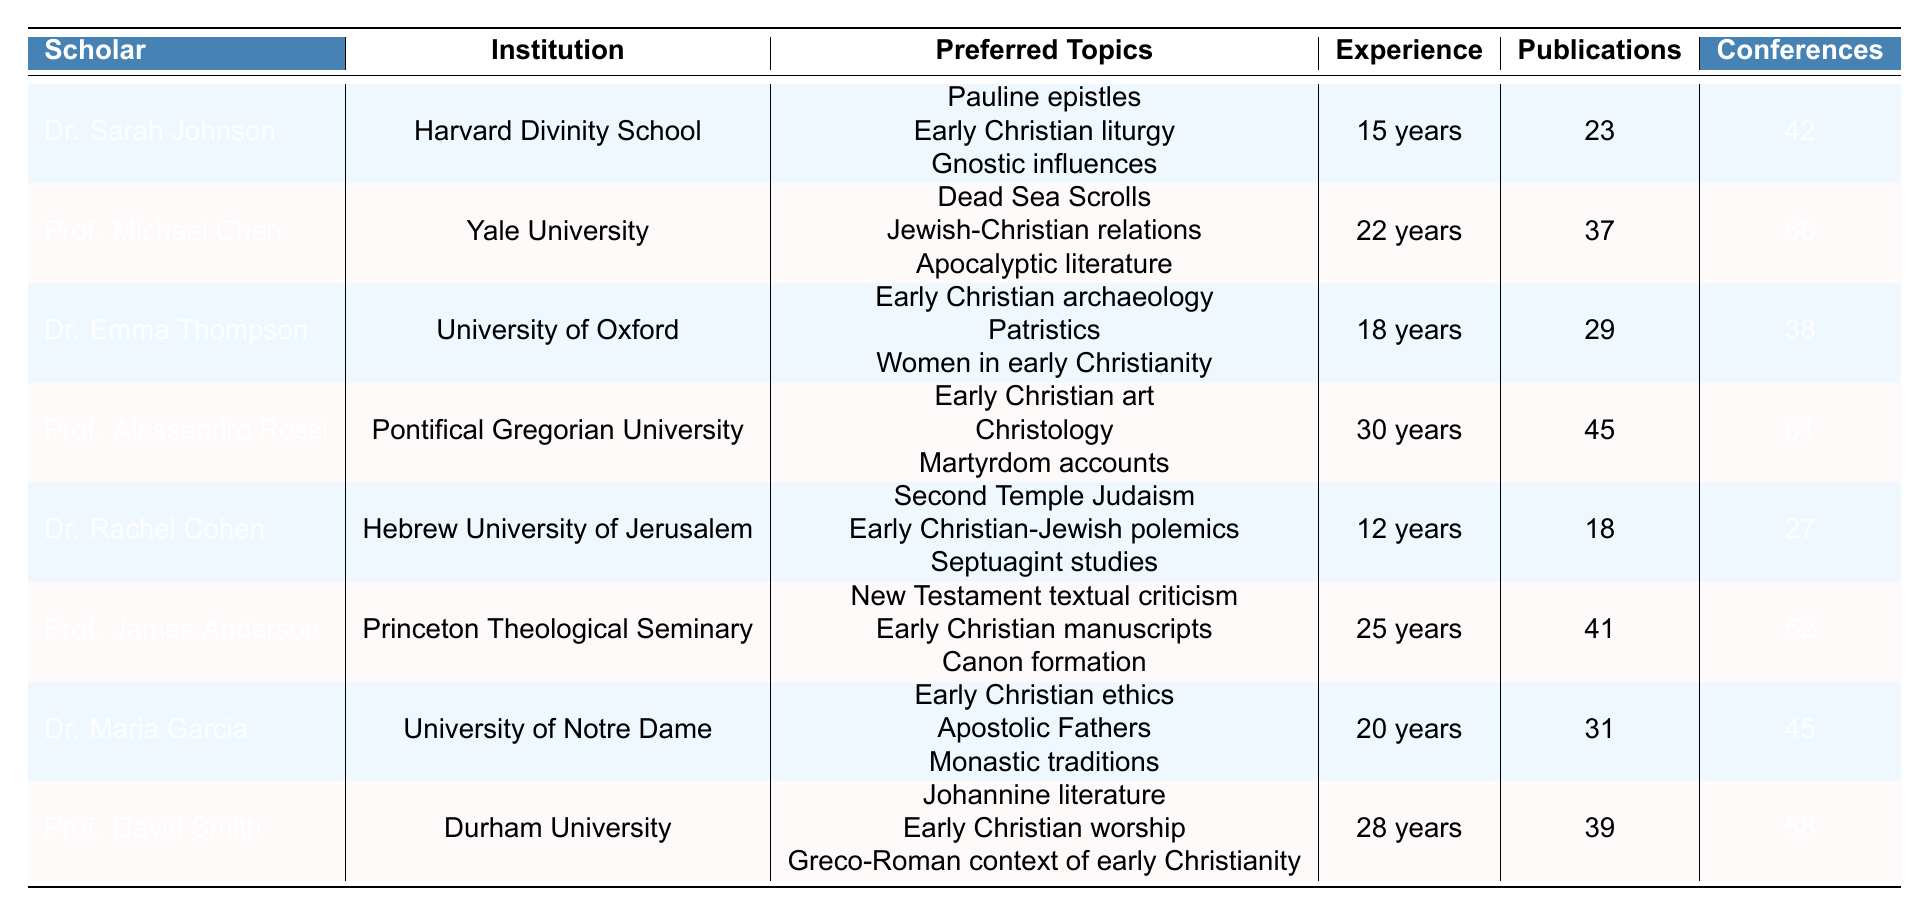What is the preferred topic of Dr. Emma Thompson? According to the table, Dr. Emma Thompson's preferred topics include Early Christian archaeology, Patristics, and Women in early Christianity.
Answer: Early Christian archaeology, Patristics, Women in early Christianity Which scholar has the highest number of publications? The table shows that Prof. Alessandro Rossi has the highest number of publications with a total of 45.
Answer: Prof. Alessandro Rossi How many years of experience does Prof. Michael Chen have? From the table, Prof. Michael Chen has 22 years of experience.
Answer: 22 years What is the total number of conferences attended by Dr. Rachel Cohen and Dr. Maria Garcia combined? Dr. Rachel Cohen attended 27 conferences, and Dr. Maria Garcia attended 45 conferences. Adding these gives 27 + 45 = 72.
Answer: 72 Which scholar specializes in Pauline epistles? The table indicates that Dr. Sarah Johnson specializes in Pauline epistles among her preferred topics.
Answer: Dr. Sarah Johnson True or False: Dr. Emma Thompson has attended more conferences than Prof. James Anderson. According to the table, Dr. Emma Thompson attended 38 conferences while Prof. James Anderson attended 52. Thus, the statement is false.
Answer: False What is the average number of publications across all scholars listed in the table? The total number of publications is 23 + 37 + 29 + 45 + 18 + 41 + 31 + 39 = 263. There are 8 scholars, so the average is 263/8 = 32.875.
Answer: 32.875 What is the difference in years of experience between Prof. David Smith and Dr. Rachel Cohen? Prof. David Smith has 28 years of experience, while Dr. Rachel Cohen has 12. The difference is 28 - 12 = 16 years.
Answer: 16 years Which institution has the scholar with the most years of experience? Prof. Alessandro Rossi from the Pontifical Gregorian University has the most years of experience at 30.
Answer: Pontifical Gregorian University How many scholars focus on topics related to early Christian worship or liturgy? Dr. Sarah Johnson focuses on Early Christian liturgy and Prof. David Smith focuses on Early Christian worship. So, there are 2 scholars.
Answer: 2 